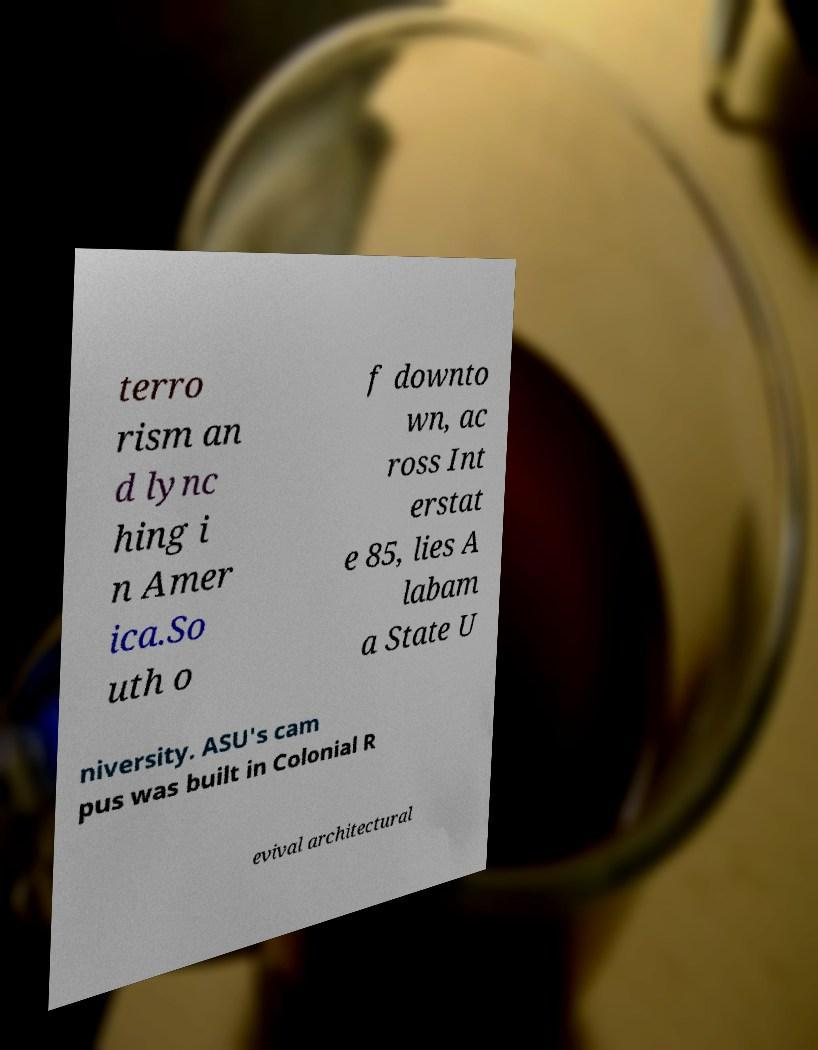What messages or text are displayed in this image? I need them in a readable, typed format. terro rism an d lync hing i n Amer ica.So uth o f downto wn, ac ross Int erstat e 85, lies A labam a State U niversity. ASU's cam pus was built in Colonial R evival architectural 